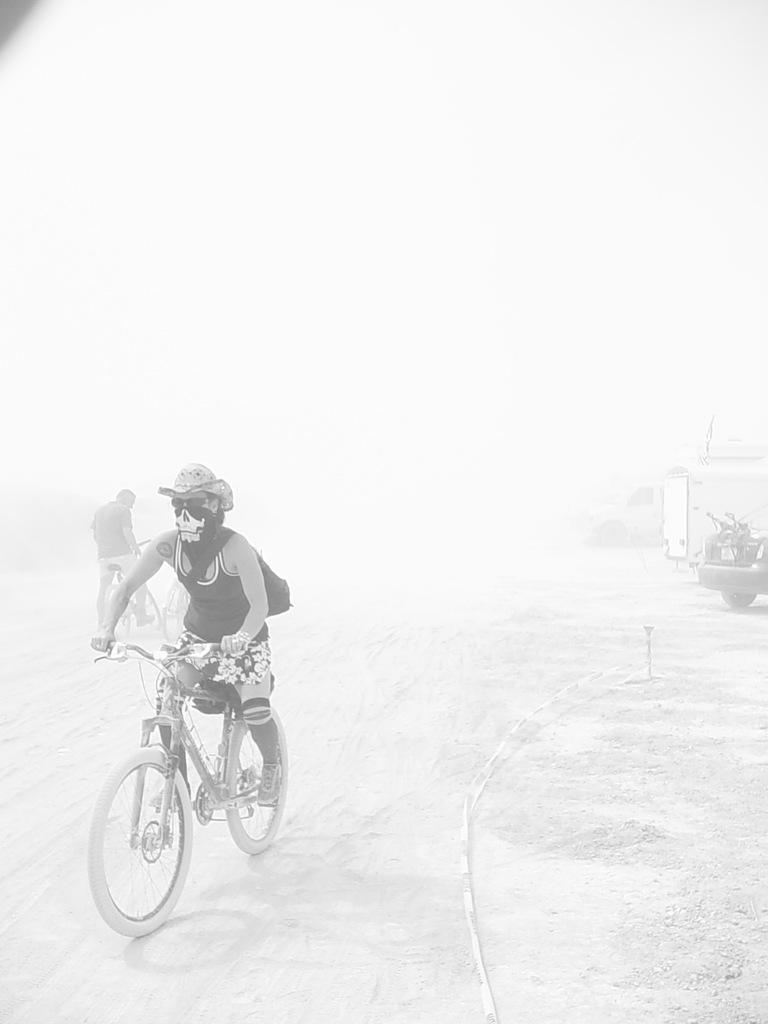Please provide a concise description of this image. There is a person riding a bicycle. There is also another person is holding a bicycle in his hands. There is a car on the right side. 